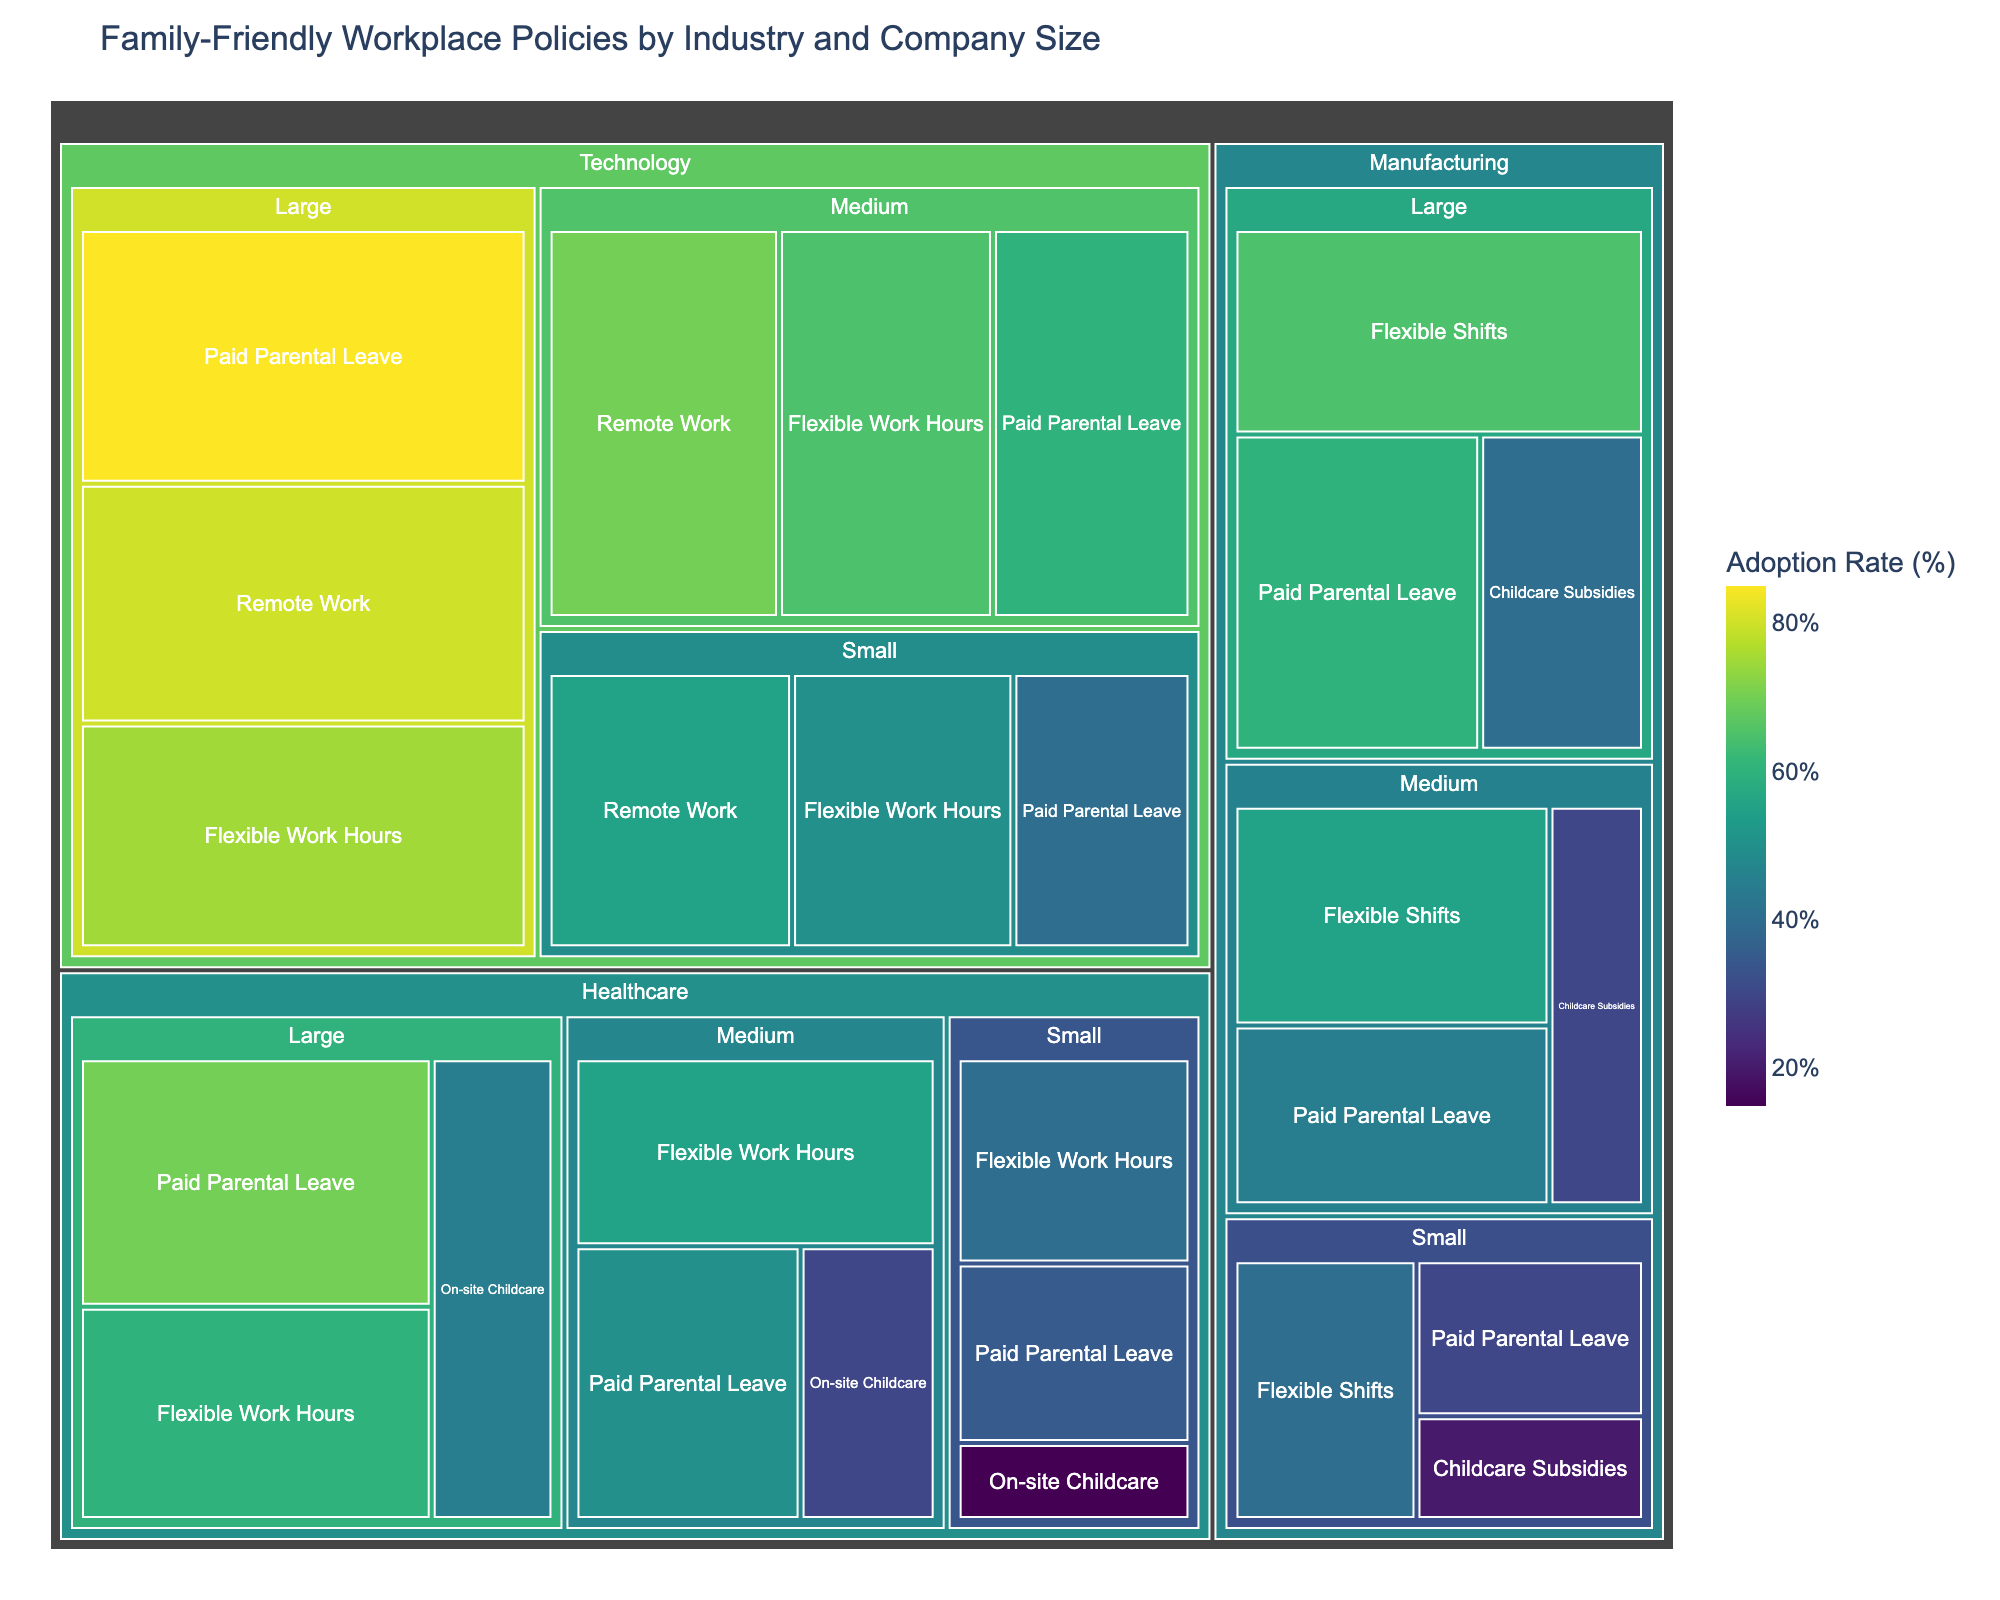What is the adoption rate of Flexible Work Hours in large technology companies? Look at the Technology section, then within that, find the Large company size and the Flexible Work Hours policy. The adoption rate listed is 75%.
Answer: 75% Which industry and policy combination has the lowest adoption rate? Scan through all sections focusing on the adoption rate values. The Healthcare industry with Small company size and On-site Childcare policy has the lowest adoption rate of 15%.
Answer: Healthcare, Small, On-site Childcare How does the adoption rate of Paid Parental Leave in medium-sized healthcare companies compare to that in large healthcare companies? Find the Healthcare industry and compare the Paid Parental Leave adoption rate for Medium and Large company sizes. Medium has 50% and Large has 70%.
Answer: 50% vs 70% Which industry has the highest adoption rate for Remote Work policy, and what is the adoption rate? Check the Remote Work policy across various industries. The Technology sector with Large companies has the highest adoption rate at 80%.
Answer: Technology, 80% What is the average adoption rate of Paid Parental Leave across all company sizes in the Manufacturing industry? Find the Paid Parental Leave policy in Manufacturing industry for Large (60%), Medium (45%), and Small (30%) companies. Compute the average by summing these rates and dividing by three: (60 + 45 + 30) / 3 = 45%.
Answer: 45% Which size category of companies in the Technology industry has the lowest adoption rate for Flexible Work Hours? Look within the Technology industry at Flexible Work Hours policy for Small (50%), Medium (65%), and Large (75%) companies. The lowest is 50% in small companies.
Answer: Small What is the total adoption rate of On-site Childcare policies across all company sizes in the Healthcare industry? Sum the adoption rates for On-site Childcare in Healthcare: Large (45%), Medium (30%), and Small (15%): 45 + 30 + 15 = 90%.
Answer: 90% How does the adoption rate for Paid Parental Leave in small companies within the Technology sector compare to that in small companies within the Healthcare sector? For the Technology sector with Small companies, the Paid Parental Leave adoption rate is 40%. In the Healthcare sector with Small companies, it is 35%.
Answer: 40% vs 35% What's the difference between the highest and lowest adoption rates for any policy in the Manufacturing sector? Find the highest adoption rate (Flexible Shifts, Large: 65%) and the lowest adoption rate (Childcare Subsidies, Small: 20%) in the Manufacturing sector. Compute the difference: 65 - 20 = 45.
Answer: 45 Which company size in the Manufacturing industry has the highest adoption rate for Childcare Subsidies, and what is the adoption rate? Look at Childcare Subsidies policy in the Manufacturing sector for different company sizes and find that Large companies have the highest adoption rate at 40%.
Answer: Large, 40% 